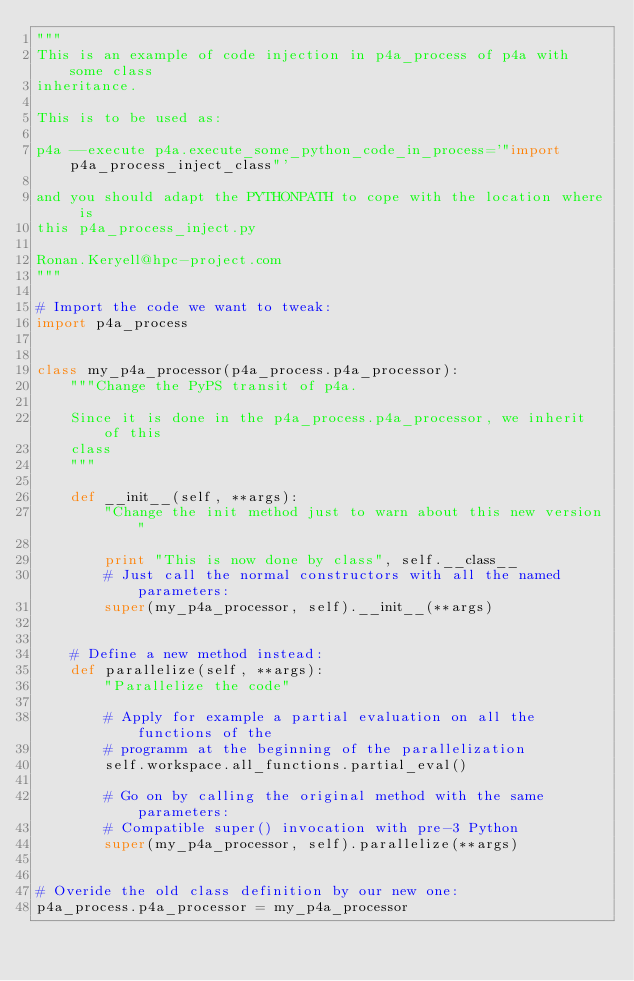Convert code to text. <code><loc_0><loc_0><loc_500><loc_500><_Python_>"""
This is an example of code injection in p4a_process of p4a with some class
inheritance.

This is to be used as:

p4a --execute p4a.execute_some_python_code_in_process='"import p4a_process_inject_class"'

and you should adapt the PYTHONPATH to cope with the location where is
this p4a_process_inject.py

Ronan.Keryell@hpc-project.com
"""

# Import the code we want to tweak:
import p4a_process


class my_p4a_processor(p4a_process.p4a_processor):
    """Change the PyPS transit of p4a.

    Since it is done in the p4a_process.p4a_processor, we inherit of this
    class
    """

    def __init__(self, **args):
        "Change the init method just to warn about this new version"

        print "This is now done by class", self.__class__
        # Just call the normal constructors with all the named parameters:
        super(my_p4a_processor, self).__init__(**args)


    # Define a new method instead:
    def parallelize(self, **args):
        "Parallelize the code"

        # Apply for example a partial evaluation on all the functions of the
        # programm at the beginning of the parallelization
        self.workspace.all_functions.partial_eval()

        # Go on by calling the original method with the same parameters:
        # Compatible super() invocation with pre-3 Python
        super(my_p4a_processor, self).parallelize(**args)


# Overide the old class definition by our new one:
p4a_process.p4a_processor = my_p4a_processor
</code> 